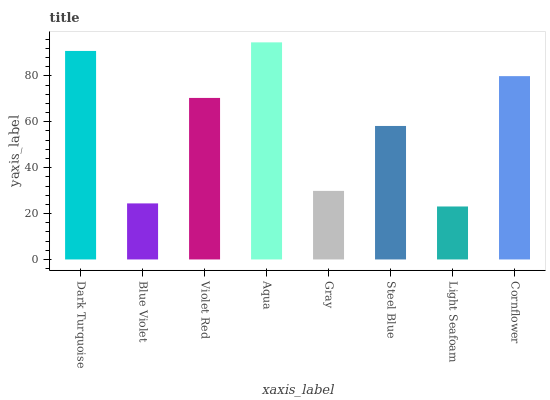Is Light Seafoam the minimum?
Answer yes or no. Yes. Is Aqua the maximum?
Answer yes or no. Yes. Is Blue Violet the minimum?
Answer yes or no. No. Is Blue Violet the maximum?
Answer yes or no. No. Is Dark Turquoise greater than Blue Violet?
Answer yes or no. Yes. Is Blue Violet less than Dark Turquoise?
Answer yes or no. Yes. Is Blue Violet greater than Dark Turquoise?
Answer yes or no. No. Is Dark Turquoise less than Blue Violet?
Answer yes or no. No. Is Violet Red the high median?
Answer yes or no. Yes. Is Steel Blue the low median?
Answer yes or no. Yes. Is Light Seafoam the high median?
Answer yes or no. No. Is Cornflower the low median?
Answer yes or no. No. 